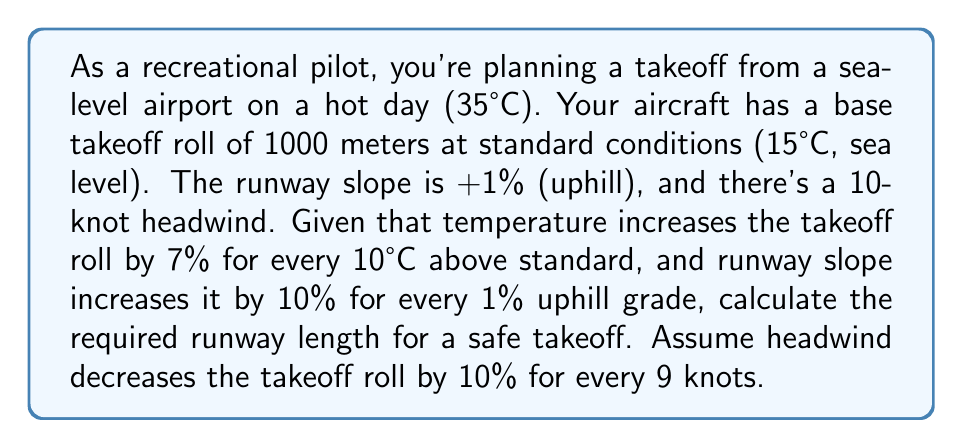Help me with this question. Let's break this down step-by-step:

1) First, we need to calculate the temperature effect:
   Temperature difference = 35°C - 15°C = 20°C
   Increase due to temperature = $7\% \times \frac{20°C}{10°C} = 14\%$
   
   Takeoff roll after temperature adjustment = $1000m \times (1 + 0.14) = 1140m$

2) Next, we account for the runway slope:
   Slope effect = $10\% \times 1\% = 10\%$
   
   Takeoff roll after slope adjustment = $1140m \times (1 + 0.10) = 1254m$

3) Finally, we consider the headwind:
   Headwind effect = $10\% \times \frac{10 \text{ knots}}{9 \text{ knots}} \approx 11.11\%$
   
   Takeoff roll after headwind adjustment = $1254m \times (1 - 0.1111) \approx 1114.8m$

4) Rounding up for safety, we get 1115 meters as the required runway length.

The calculation can be summarized in one formula:

$$\text{Required Length} = 1000m \times (1 + 0.14) \times (1 + 0.10) \times (1 - 0.1111) \approx 1114.8m$$
Answer: 1115 meters 